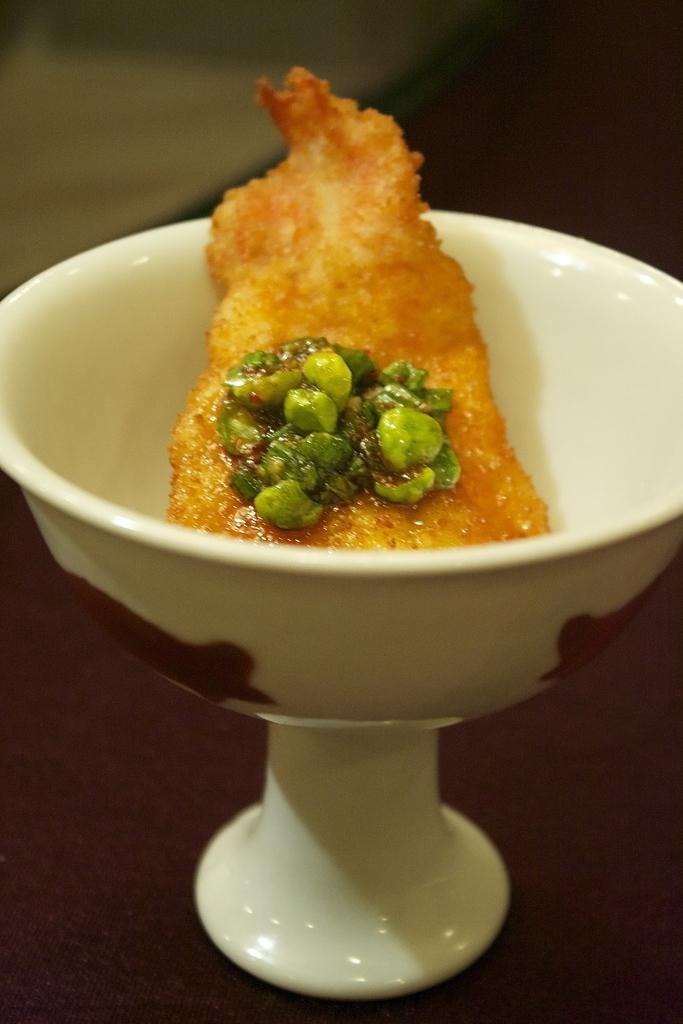What is placed in a bowl in the image? There is an eatable item placed in a bowl in the image. What type of tank is visible in the image? There is no tank present in the image; it only features an eatable item placed in a bowl. 